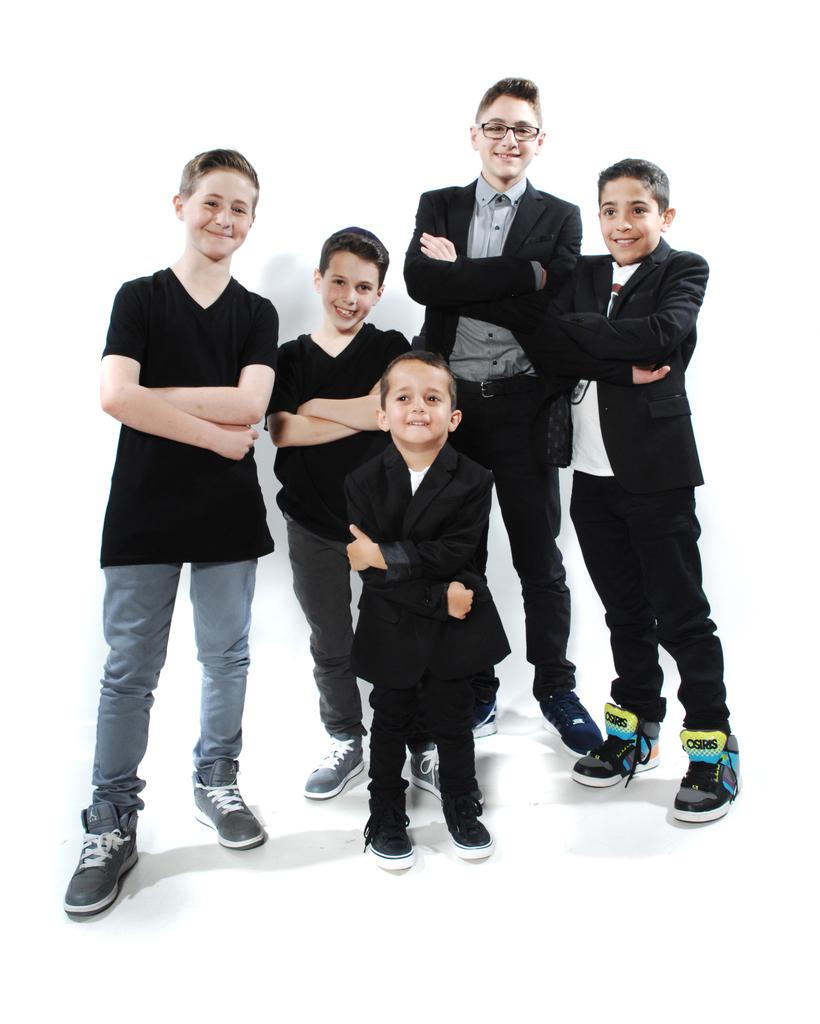How many people are in the image? There are five boys in the image. What are the boys doing in the image? The boys are standing in the image. What expressions do the boys have in the image? The boys are smiling in the image. What color is the background of the image? The background of the image is white. What type of addition problem can be solved by the boys in the image? There is no addition problem present in the image, as it features five boys standing and smiling. Which actor is performing in the image? There is no actor present in the image, as it features five boys standing and smiling. 